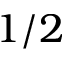<formula> <loc_0><loc_0><loc_500><loc_500>1 / 2</formula> 